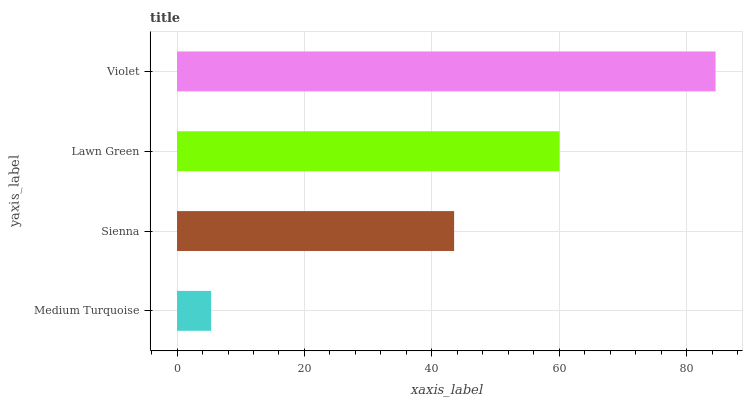Is Medium Turquoise the minimum?
Answer yes or no. Yes. Is Violet the maximum?
Answer yes or no. Yes. Is Sienna the minimum?
Answer yes or no. No. Is Sienna the maximum?
Answer yes or no. No. Is Sienna greater than Medium Turquoise?
Answer yes or no. Yes. Is Medium Turquoise less than Sienna?
Answer yes or no. Yes. Is Medium Turquoise greater than Sienna?
Answer yes or no. No. Is Sienna less than Medium Turquoise?
Answer yes or no. No. Is Lawn Green the high median?
Answer yes or no. Yes. Is Sienna the low median?
Answer yes or no. Yes. Is Medium Turquoise the high median?
Answer yes or no. No. Is Violet the low median?
Answer yes or no. No. 